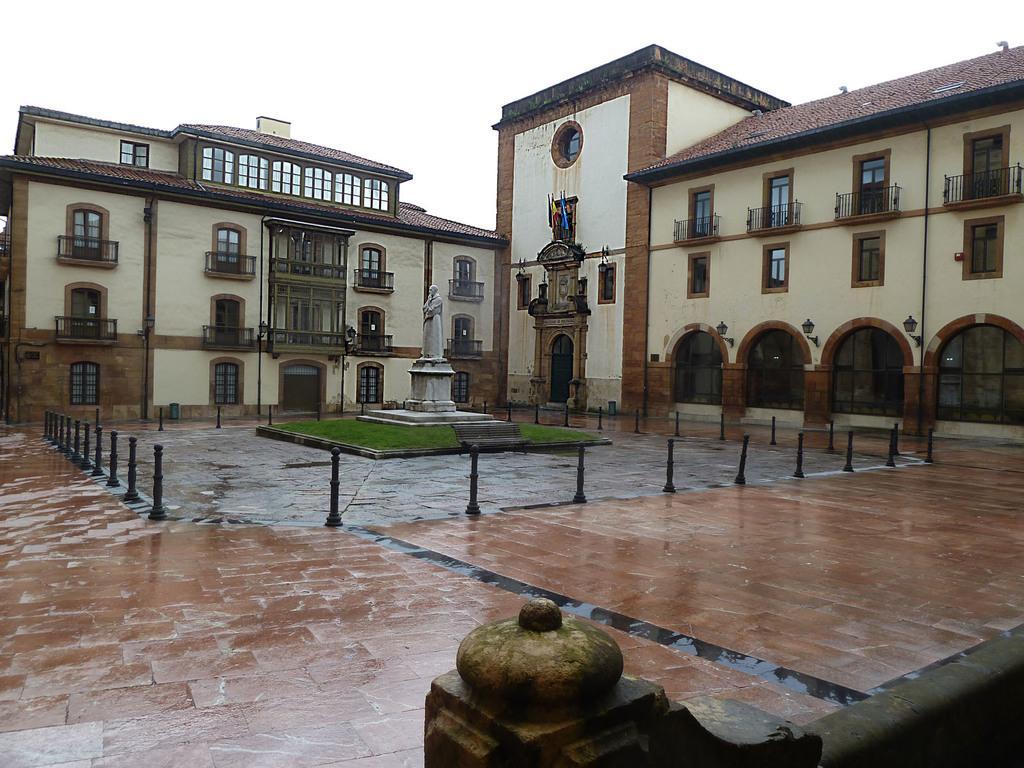Could you give a brief overview of what you see in this image? In this image we can see buildings, statue, pedestal, ground, barrier poles and sky. 